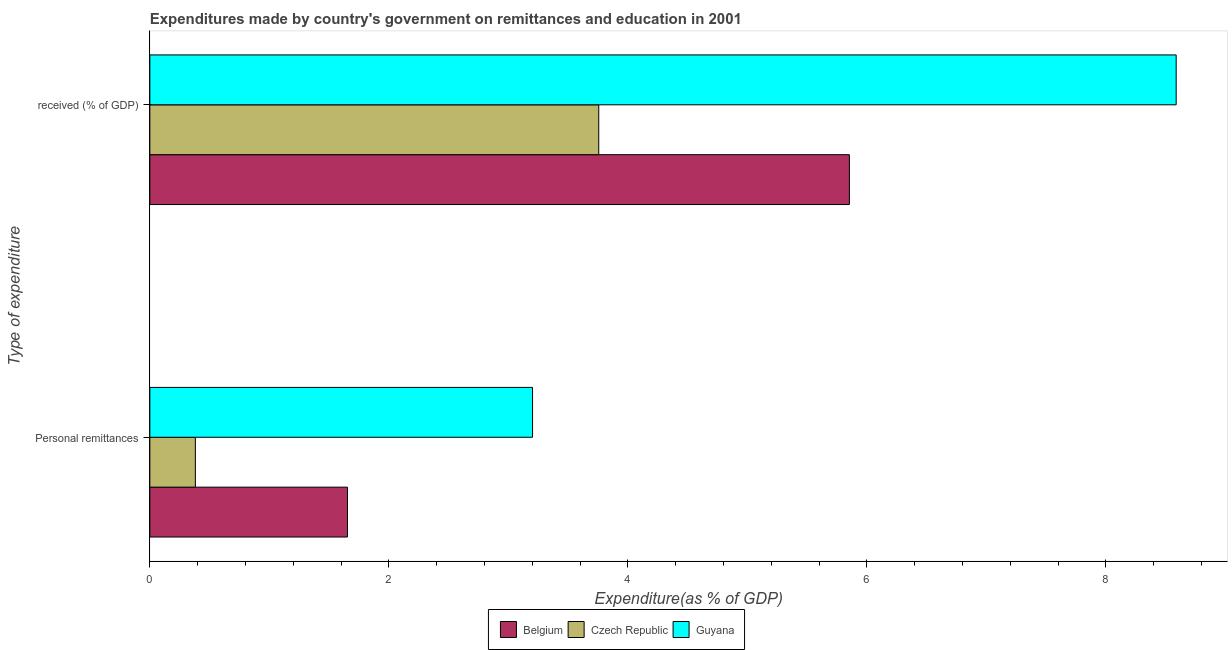How many groups of bars are there?
Give a very brief answer. 2. Are the number of bars per tick equal to the number of legend labels?
Offer a very short reply. Yes. Are the number of bars on each tick of the Y-axis equal?
Keep it short and to the point. Yes. How many bars are there on the 1st tick from the top?
Provide a short and direct response. 3. How many bars are there on the 1st tick from the bottom?
Your answer should be compact. 3. What is the label of the 1st group of bars from the top?
Offer a very short reply.  received (% of GDP). What is the expenditure in education in Belgium?
Offer a terse response. 5.85. Across all countries, what is the maximum expenditure in personal remittances?
Provide a short and direct response. 3.2. Across all countries, what is the minimum expenditure in education?
Offer a terse response. 3.76. In which country was the expenditure in education maximum?
Give a very brief answer. Guyana. In which country was the expenditure in personal remittances minimum?
Ensure brevity in your answer.  Czech Republic. What is the total expenditure in personal remittances in the graph?
Keep it short and to the point. 5.24. What is the difference between the expenditure in personal remittances in Czech Republic and that in Belgium?
Ensure brevity in your answer.  -1.27. What is the difference between the expenditure in education in Belgium and the expenditure in personal remittances in Guyana?
Give a very brief answer. 2.65. What is the average expenditure in education per country?
Give a very brief answer. 6.07. What is the difference between the expenditure in personal remittances and expenditure in education in Czech Republic?
Provide a succinct answer. -3.38. What is the ratio of the expenditure in education in Guyana to that in Czech Republic?
Your response must be concise. 2.29. In how many countries, is the expenditure in education greater than the average expenditure in education taken over all countries?
Keep it short and to the point. 1. What does the 1st bar from the top in  received (% of GDP) represents?
Keep it short and to the point. Guyana. What does the 2nd bar from the bottom in  received (% of GDP) represents?
Offer a terse response. Czech Republic. How many countries are there in the graph?
Offer a terse response. 3. What is the title of the graph?
Keep it short and to the point. Expenditures made by country's government on remittances and education in 2001. What is the label or title of the X-axis?
Make the answer very short. Expenditure(as % of GDP). What is the label or title of the Y-axis?
Provide a succinct answer. Type of expenditure. What is the Expenditure(as % of GDP) in Belgium in Personal remittances?
Your response must be concise. 1.65. What is the Expenditure(as % of GDP) in Czech Republic in Personal remittances?
Give a very brief answer. 0.38. What is the Expenditure(as % of GDP) of Guyana in Personal remittances?
Give a very brief answer. 3.2. What is the Expenditure(as % of GDP) in Belgium in  received (% of GDP)?
Provide a short and direct response. 5.85. What is the Expenditure(as % of GDP) of Czech Republic in  received (% of GDP)?
Keep it short and to the point. 3.76. What is the Expenditure(as % of GDP) in Guyana in  received (% of GDP)?
Keep it short and to the point. 8.59. Across all Type of expenditure, what is the maximum Expenditure(as % of GDP) in Belgium?
Keep it short and to the point. 5.85. Across all Type of expenditure, what is the maximum Expenditure(as % of GDP) in Czech Republic?
Offer a terse response. 3.76. Across all Type of expenditure, what is the maximum Expenditure(as % of GDP) of Guyana?
Provide a succinct answer. 8.59. Across all Type of expenditure, what is the minimum Expenditure(as % of GDP) of Belgium?
Give a very brief answer. 1.65. Across all Type of expenditure, what is the minimum Expenditure(as % of GDP) in Czech Republic?
Ensure brevity in your answer.  0.38. Across all Type of expenditure, what is the minimum Expenditure(as % of GDP) in Guyana?
Make the answer very short. 3.2. What is the total Expenditure(as % of GDP) of Belgium in the graph?
Make the answer very short. 7.51. What is the total Expenditure(as % of GDP) of Czech Republic in the graph?
Make the answer very short. 4.14. What is the total Expenditure(as % of GDP) of Guyana in the graph?
Your answer should be compact. 11.79. What is the difference between the Expenditure(as % of GDP) of Belgium in Personal remittances and that in  received (% of GDP)?
Give a very brief answer. -4.2. What is the difference between the Expenditure(as % of GDP) of Czech Republic in Personal remittances and that in  received (% of GDP)?
Your answer should be very brief. -3.38. What is the difference between the Expenditure(as % of GDP) of Guyana in Personal remittances and that in  received (% of GDP)?
Give a very brief answer. -5.39. What is the difference between the Expenditure(as % of GDP) in Belgium in Personal remittances and the Expenditure(as % of GDP) in Czech Republic in  received (% of GDP)?
Provide a succinct answer. -2.1. What is the difference between the Expenditure(as % of GDP) in Belgium in Personal remittances and the Expenditure(as % of GDP) in Guyana in  received (% of GDP)?
Offer a very short reply. -6.94. What is the difference between the Expenditure(as % of GDP) in Czech Republic in Personal remittances and the Expenditure(as % of GDP) in Guyana in  received (% of GDP)?
Give a very brief answer. -8.21. What is the average Expenditure(as % of GDP) of Belgium per Type of expenditure?
Your answer should be compact. 3.75. What is the average Expenditure(as % of GDP) of Czech Republic per Type of expenditure?
Your response must be concise. 2.07. What is the average Expenditure(as % of GDP) of Guyana per Type of expenditure?
Offer a terse response. 5.9. What is the difference between the Expenditure(as % of GDP) in Belgium and Expenditure(as % of GDP) in Czech Republic in Personal remittances?
Ensure brevity in your answer.  1.27. What is the difference between the Expenditure(as % of GDP) of Belgium and Expenditure(as % of GDP) of Guyana in Personal remittances?
Your answer should be very brief. -1.55. What is the difference between the Expenditure(as % of GDP) in Czech Republic and Expenditure(as % of GDP) in Guyana in Personal remittances?
Ensure brevity in your answer.  -2.82. What is the difference between the Expenditure(as % of GDP) in Belgium and Expenditure(as % of GDP) in Czech Republic in  received (% of GDP)?
Offer a terse response. 2.1. What is the difference between the Expenditure(as % of GDP) in Belgium and Expenditure(as % of GDP) in Guyana in  received (% of GDP)?
Offer a terse response. -2.73. What is the difference between the Expenditure(as % of GDP) in Czech Republic and Expenditure(as % of GDP) in Guyana in  received (% of GDP)?
Your answer should be compact. -4.83. What is the ratio of the Expenditure(as % of GDP) of Belgium in Personal remittances to that in  received (% of GDP)?
Ensure brevity in your answer.  0.28. What is the ratio of the Expenditure(as % of GDP) in Czech Republic in Personal remittances to that in  received (% of GDP)?
Your response must be concise. 0.1. What is the ratio of the Expenditure(as % of GDP) in Guyana in Personal remittances to that in  received (% of GDP)?
Ensure brevity in your answer.  0.37. What is the difference between the highest and the second highest Expenditure(as % of GDP) of Belgium?
Ensure brevity in your answer.  4.2. What is the difference between the highest and the second highest Expenditure(as % of GDP) of Czech Republic?
Offer a terse response. 3.38. What is the difference between the highest and the second highest Expenditure(as % of GDP) of Guyana?
Provide a short and direct response. 5.39. What is the difference between the highest and the lowest Expenditure(as % of GDP) in Belgium?
Make the answer very short. 4.2. What is the difference between the highest and the lowest Expenditure(as % of GDP) in Czech Republic?
Your response must be concise. 3.38. What is the difference between the highest and the lowest Expenditure(as % of GDP) in Guyana?
Make the answer very short. 5.39. 